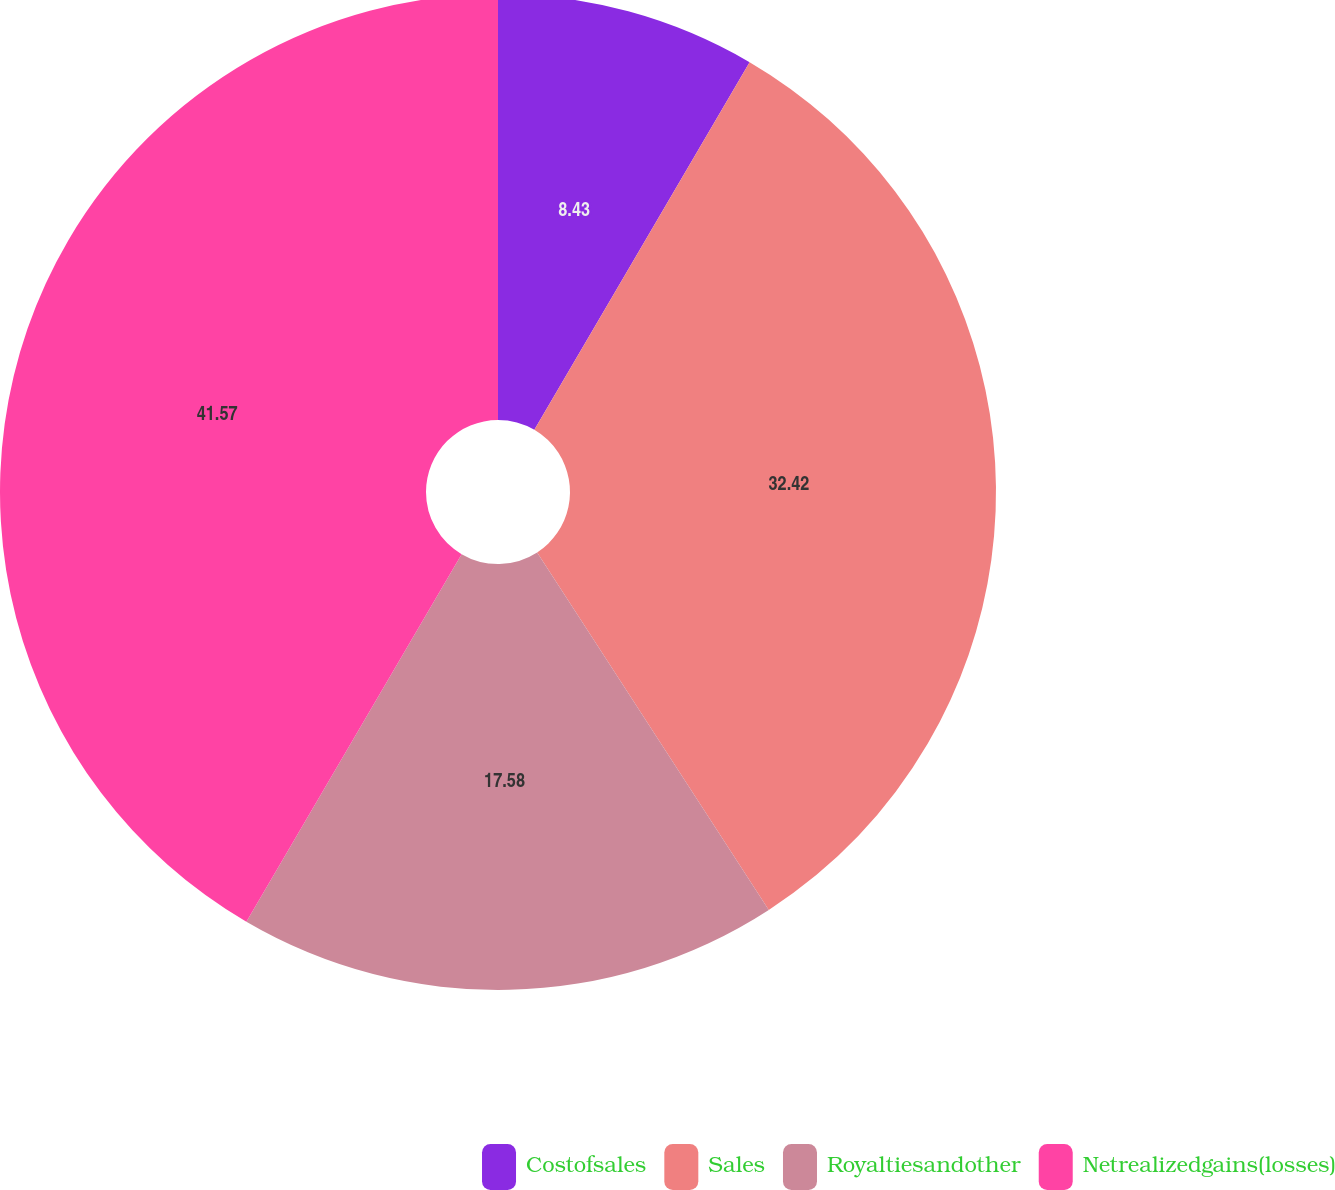<chart> <loc_0><loc_0><loc_500><loc_500><pie_chart><fcel>Costofsales<fcel>Sales<fcel>Royaltiesandother<fcel>Netrealizedgains(losses)<nl><fcel>8.43%<fcel>32.42%<fcel>17.58%<fcel>41.57%<nl></chart> 